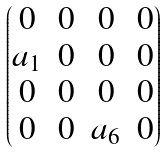<formula> <loc_0><loc_0><loc_500><loc_500>\begin{pmatrix} 0 & 0 & 0 & 0 \\ a _ { 1 } & 0 & 0 & 0 \\ 0 & 0 & 0 & 0 \\ 0 & 0 & a _ { 6 } & 0 \end{pmatrix}</formula> 